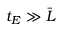Convert formula to latex. <formula><loc_0><loc_0><loc_500><loc_500>t _ { E } \gg \bar { L }</formula> 